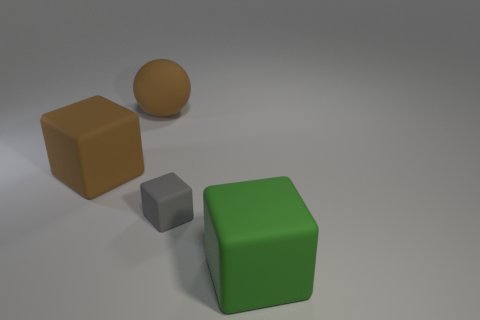Subtract all big green rubber cubes. How many cubes are left? 2 Subtract all red spheres. How many gray cubes are left? 1 Subtract all gray blocks. How many blocks are left? 2 Subtract 0 purple blocks. How many objects are left? 4 Subtract all blocks. How many objects are left? 1 Subtract 1 blocks. How many blocks are left? 2 Subtract all red blocks. Subtract all yellow cylinders. How many blocks are left? 3 Subtract all big brown rubber objects. Subtract all green things. How many objects are left? 1 Add 3 tiny gray cubes. How many tiny gray cubes are left? 4 Add 4 tiny yellow metal cubes. How many tiny yellow metal cubes exist? 4 